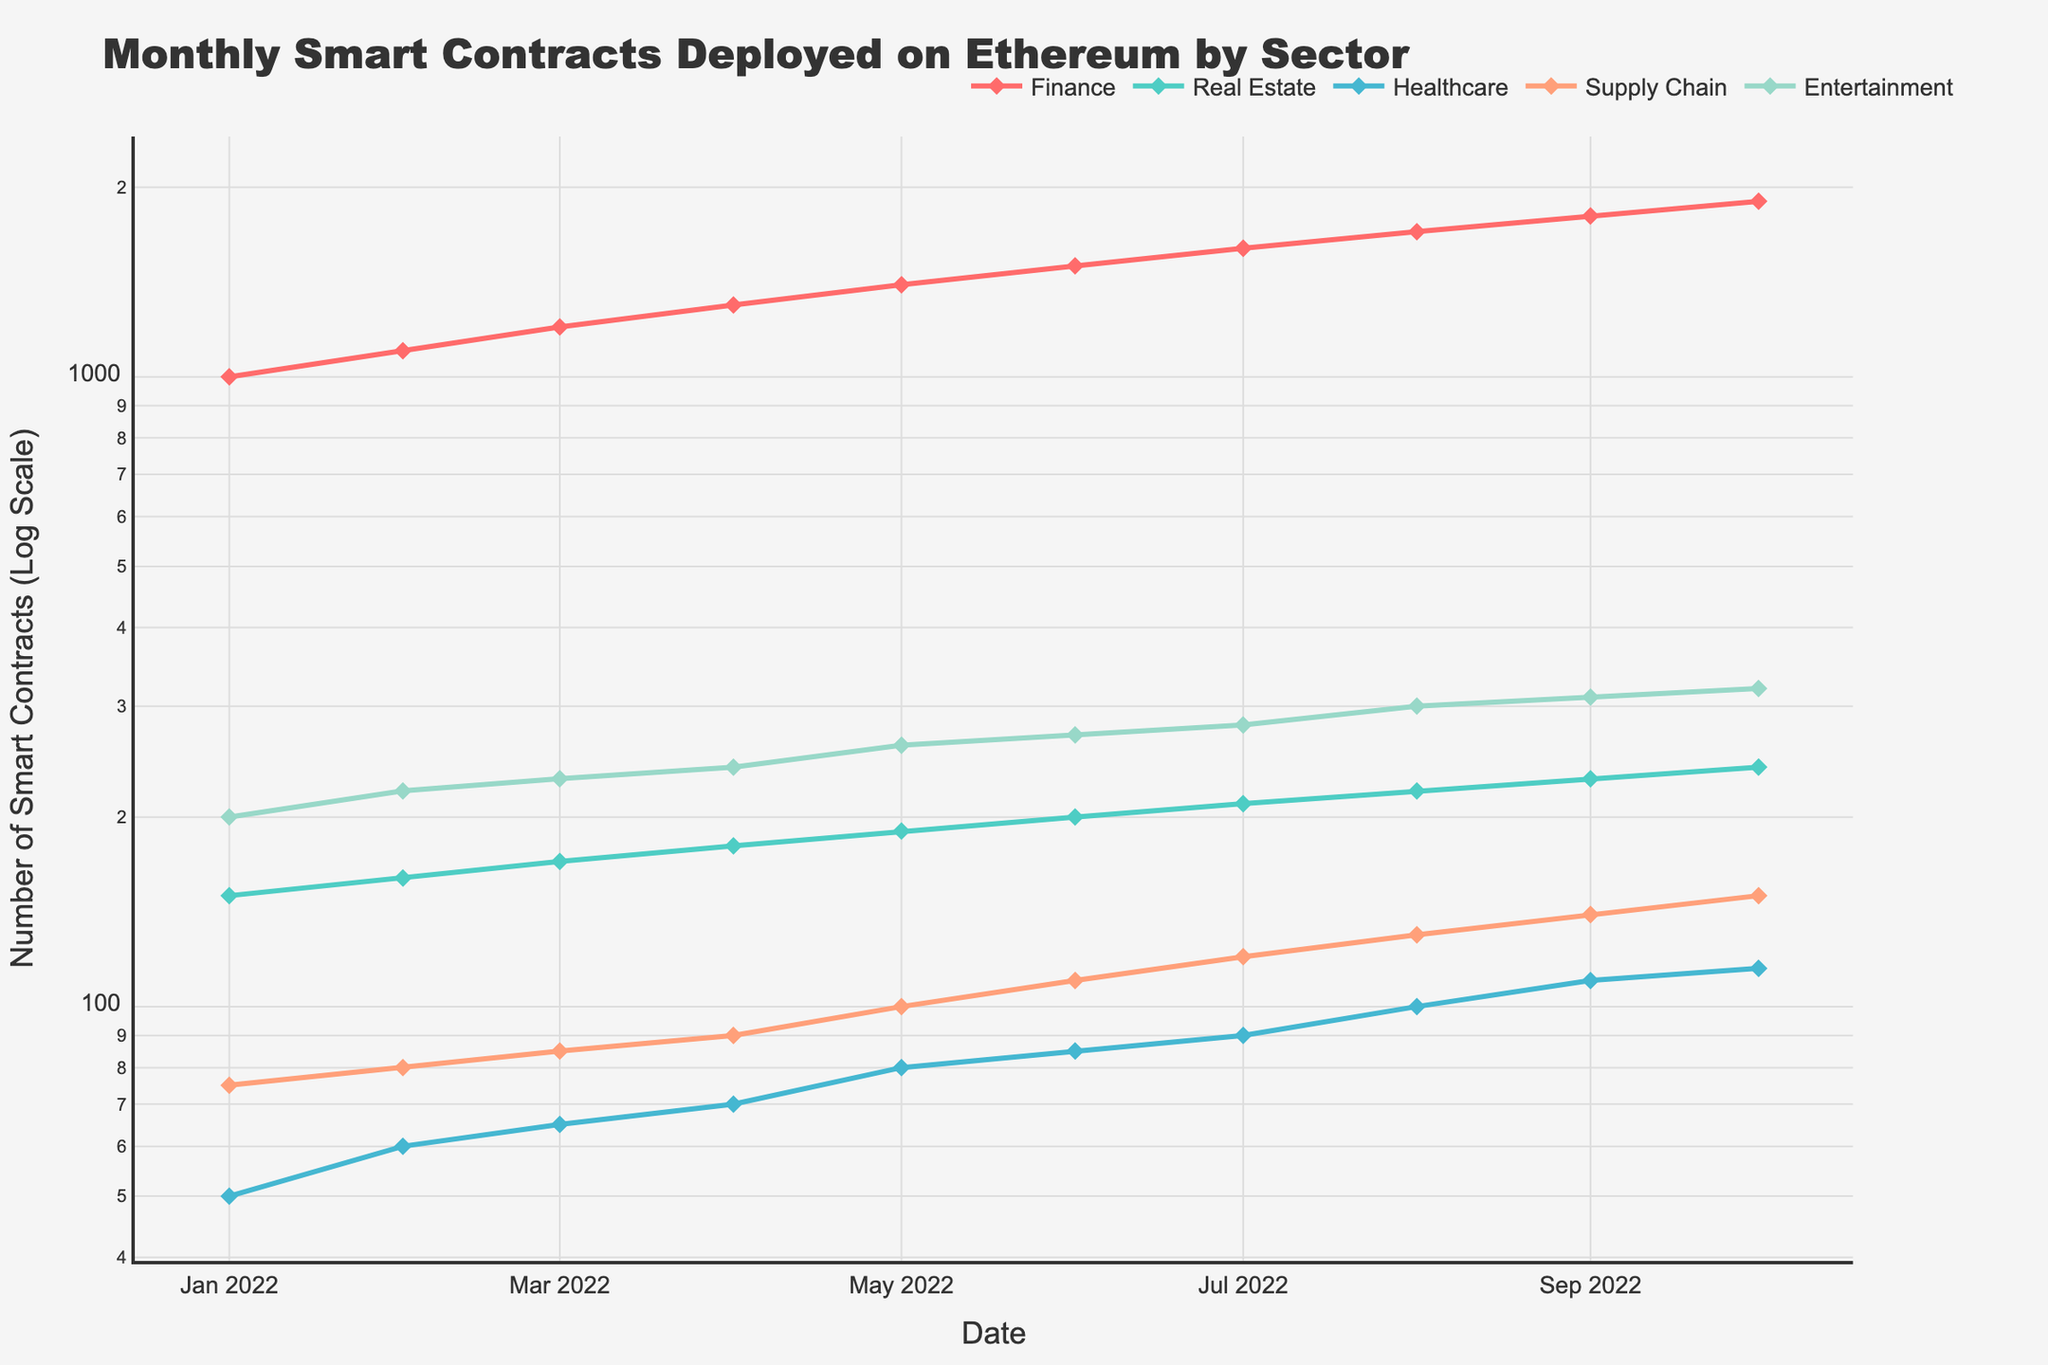What is the title of the figure? The title of the figure is typically displayed at the top of a plot. Just by looking at the top, one can see the title that explains what the plot is about.
Answer: Monthly Smart Contracts Deployed on Ethereum by Sector How many distinct sectors are represented in the plot? By counting the number of different lines and checking the legend, we can identify the number of sectors being tracked.
Answer: 5 Which sector has the highest number of smart contracts deployed in October 2022? To determine this, look at the values for each sector in October 2022. The sector with the highest value is the answer.
Answer: Finance Describe the trend in the number of smart contracts deployed in the Finance sector from January 2022 to October 2022. By following the line for the Finance sector from January to October 2022, observe whether it increases, decreases, or stays the same.
Answer: Increasing How does the number of smart contracts deployed in the Healthcare sector in August 2022 compare to those in September 2022? Locate the points for Healthcare in August and September 2022 and compare their values.
Answer: August has fewer than September What is the difference in the number of smart contracts deployed between Finance and Real Estate sectors in April 2022? Find the values for both Finance and Real Estate in April 2022, then subtract the value of Real Estate from Finance.
Answer: 1120 On average, how many smart contracts were deployed in the Supply Chain sector over the period shown? Sum the number of smart contracts deployed in the Supply Chain sector across all months and then divide by the number of months (10).
Answer: 102 Does any sector show a consistent upward trend without any drops? Examine each sector's line to see if it shows a consistent increase from one month to the next without any dips.
Answer: Finance What's the total number of smart contracts deployed across all sectors in July 2022? Add up the values for all sectors in July 2022.
Answer: 2300 Which sector has the steepest increase between January and February 2022? Look at the change in values from January to February 2022 for each sector, then the sector with the largest increase is the one with the steepest rise.
Answer: Finance 